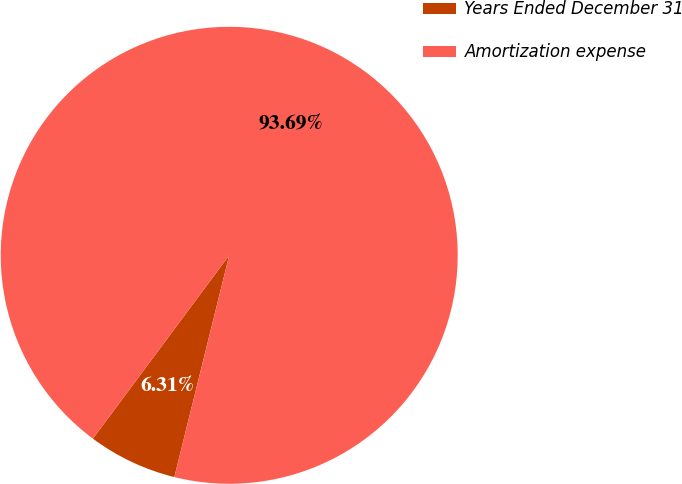<chart> <loc_0><loc_0><loc_500><loc_500><pie_chart><fcel>Years Ended December 31<fcel>Amortization expense<nl><fcel>6.31%<fcel>93.69%<nl></chart> 